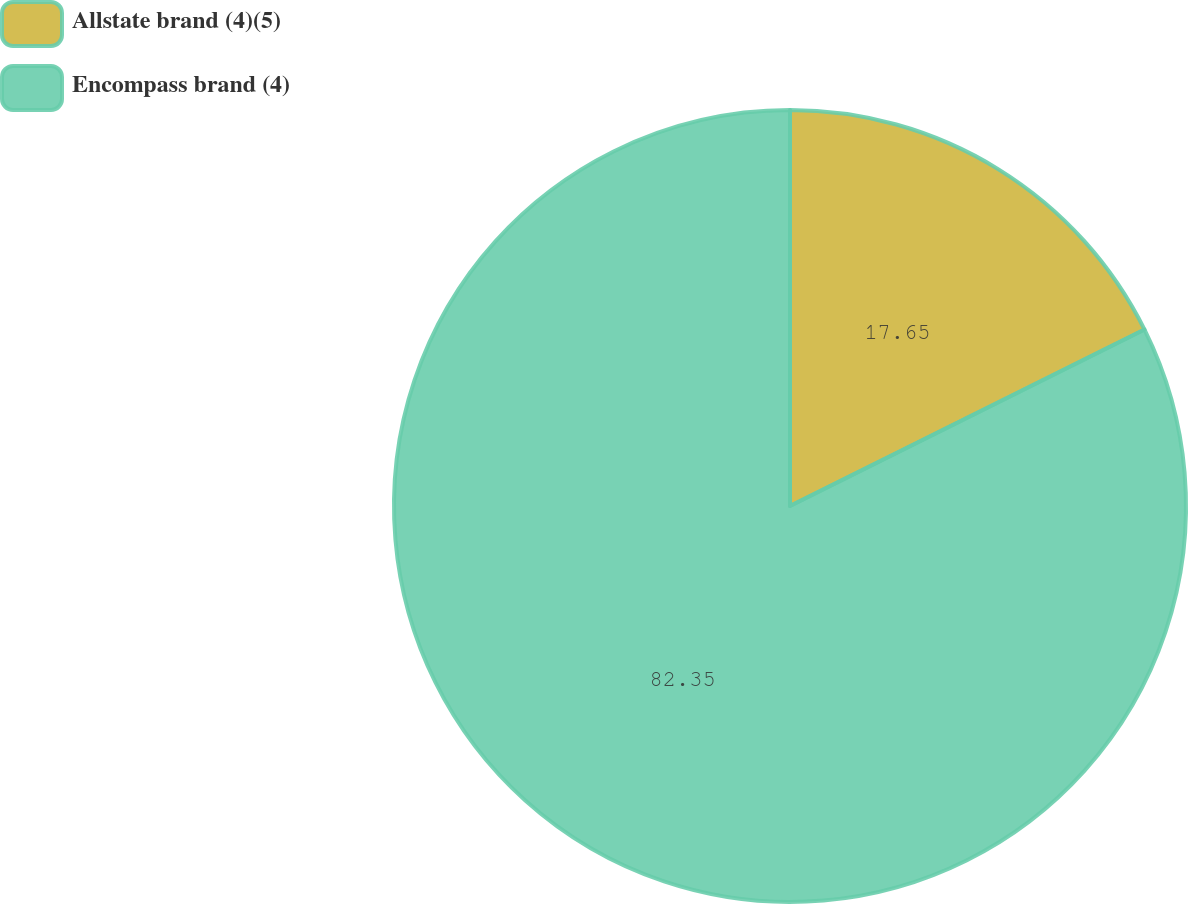Convert chart. <chart><loc_0><loc_0><loc_500><loc_500><pie_chart><fcel>Allstate brand (4)(5)<fcel>Encompass brand (4)<nl><fcel>17.65%<fcel>82.35%<nl></chart> 